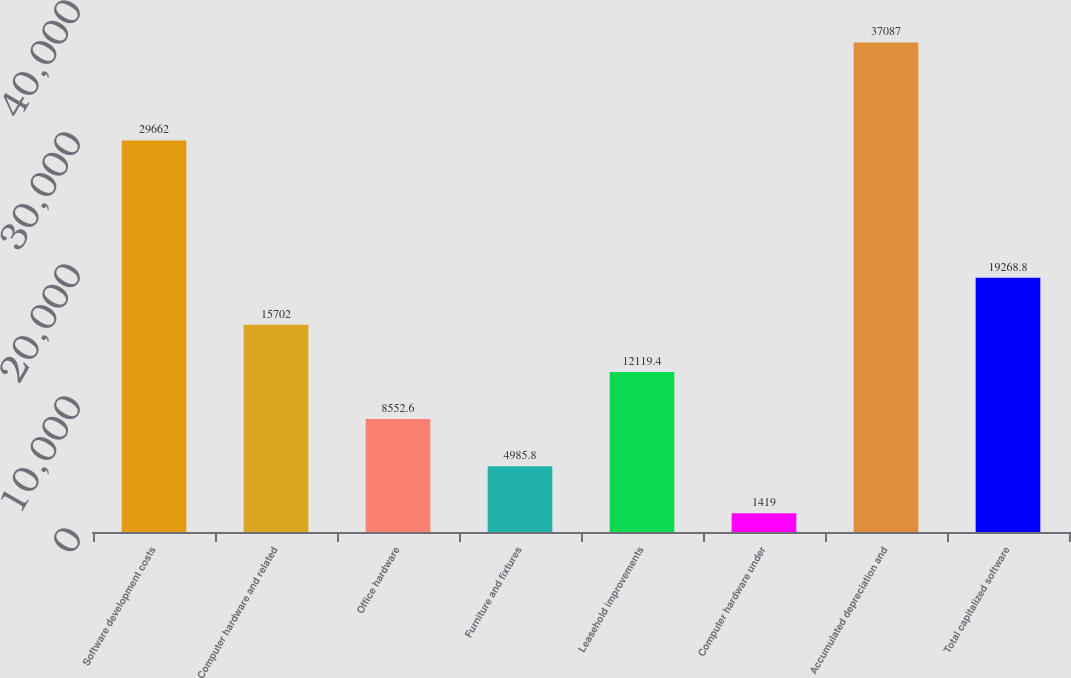Convert chart. <chart><loc_0><loc_0><loc_500><loc_500><bar_chart><fcel>Software development costs<fcel>Computer hardware and related<fcel>Office hardware<fcel>Furniture and fixtures<fcel>Leasehold improvements<fcel>Computer hardware under<fcel>Accumulated depreciation and<fcel>Total capitalized software<nl><fcel>29662<fcel>15702<fcel>8552.6<fcel>4985.8<fcel>12119.4<fcel>1419<fcel>37087<fcel>19268.8<nl></chart> 